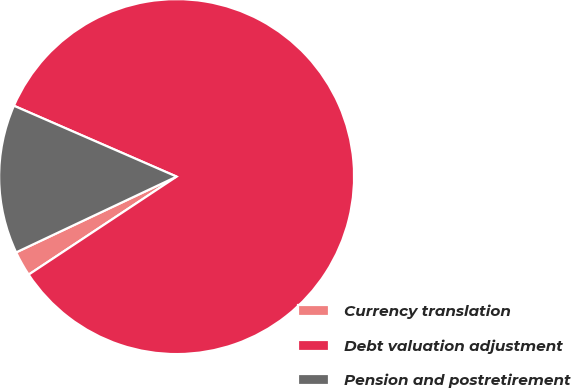Convert chart to OTSL. <chart><loc_0><loc_0><loc_500><loc_500><pie_chart><fcel>Currency translation<fcel>Debt valuation adjustment<fcel>Pension and postretirement<nl><fcel>2.29%<fcel>84.15%<fcel>13.56%<nl></chart> 